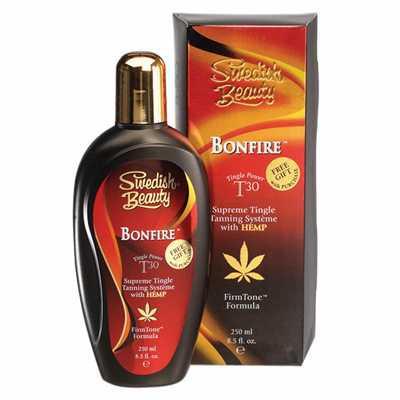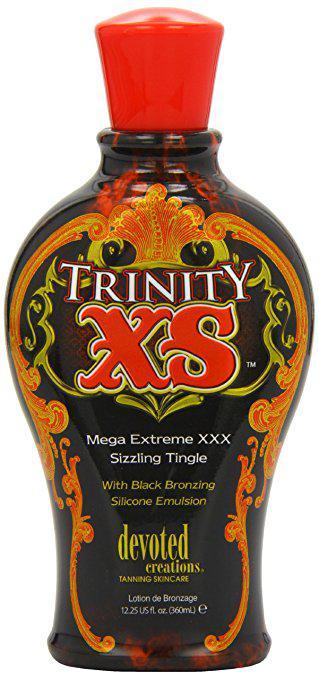The first image is the image on the left, the second image is the image on the right. For the images displayed, is the sentence "At least one of the images shows the product next to the packaging." factually correct? Answer yes or no. Yes. The first image is the image on the left, the second image is the image on the right. Evaluate the accuracy of this statement regarding the images: "One image shows a bottle standing alone, with its lid at the top, and the other image shows a bottle in front of and overlapping its upright box.". Is it true? Answer yes or no. Yes. 